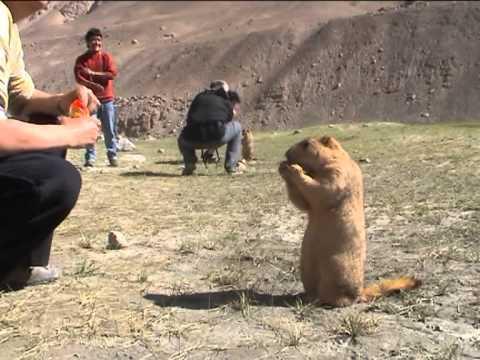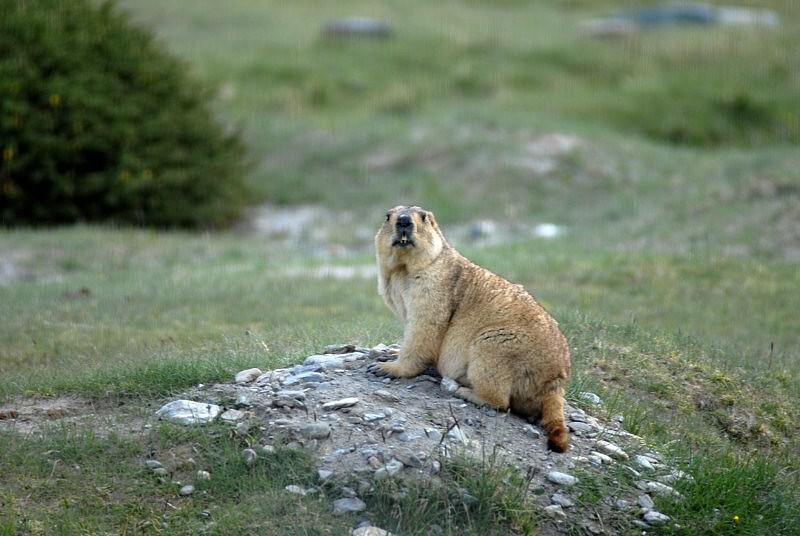The first image is the image on the left, the second image is the image on the right. Analyze the images presented: Is the assertion "There is one gopher on the left, and two gophers being affectionate on the right." valid? Answer yes or no. No. The first image is the image on the left, the second image is the image on the right. Examine the images to the left and right. Is the description "At least one animal. Is standing on it's hind legs." accurate? Answer yes or no. Yes. 